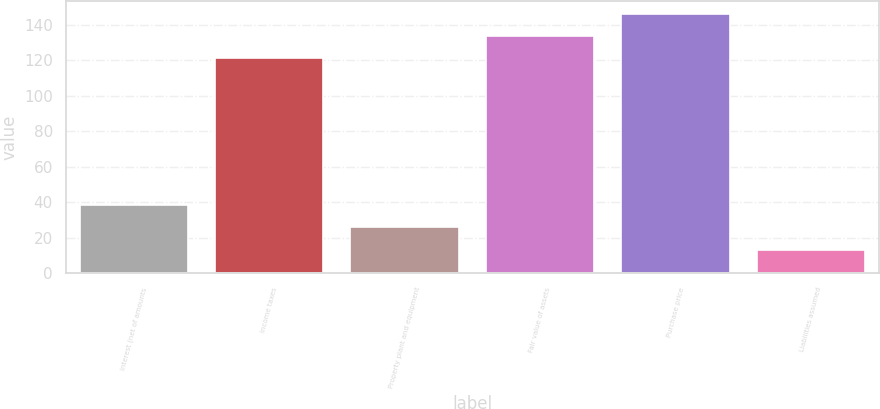<chart> <loc_0><loc_0><loc_500><loc_500><bar_chart><fcel>Interest (net of amounts<fcel>Income taxes<fcel>Property plant and equipment<fcel>Fair value of assets<fcel>Purchase price<fcel>Liabilities assumed<nl><fcel>38.43<fcel>120.9<fcel>25.92<fcel>133.41<fcel>145.92<fcel>13.41<nl></chart> 